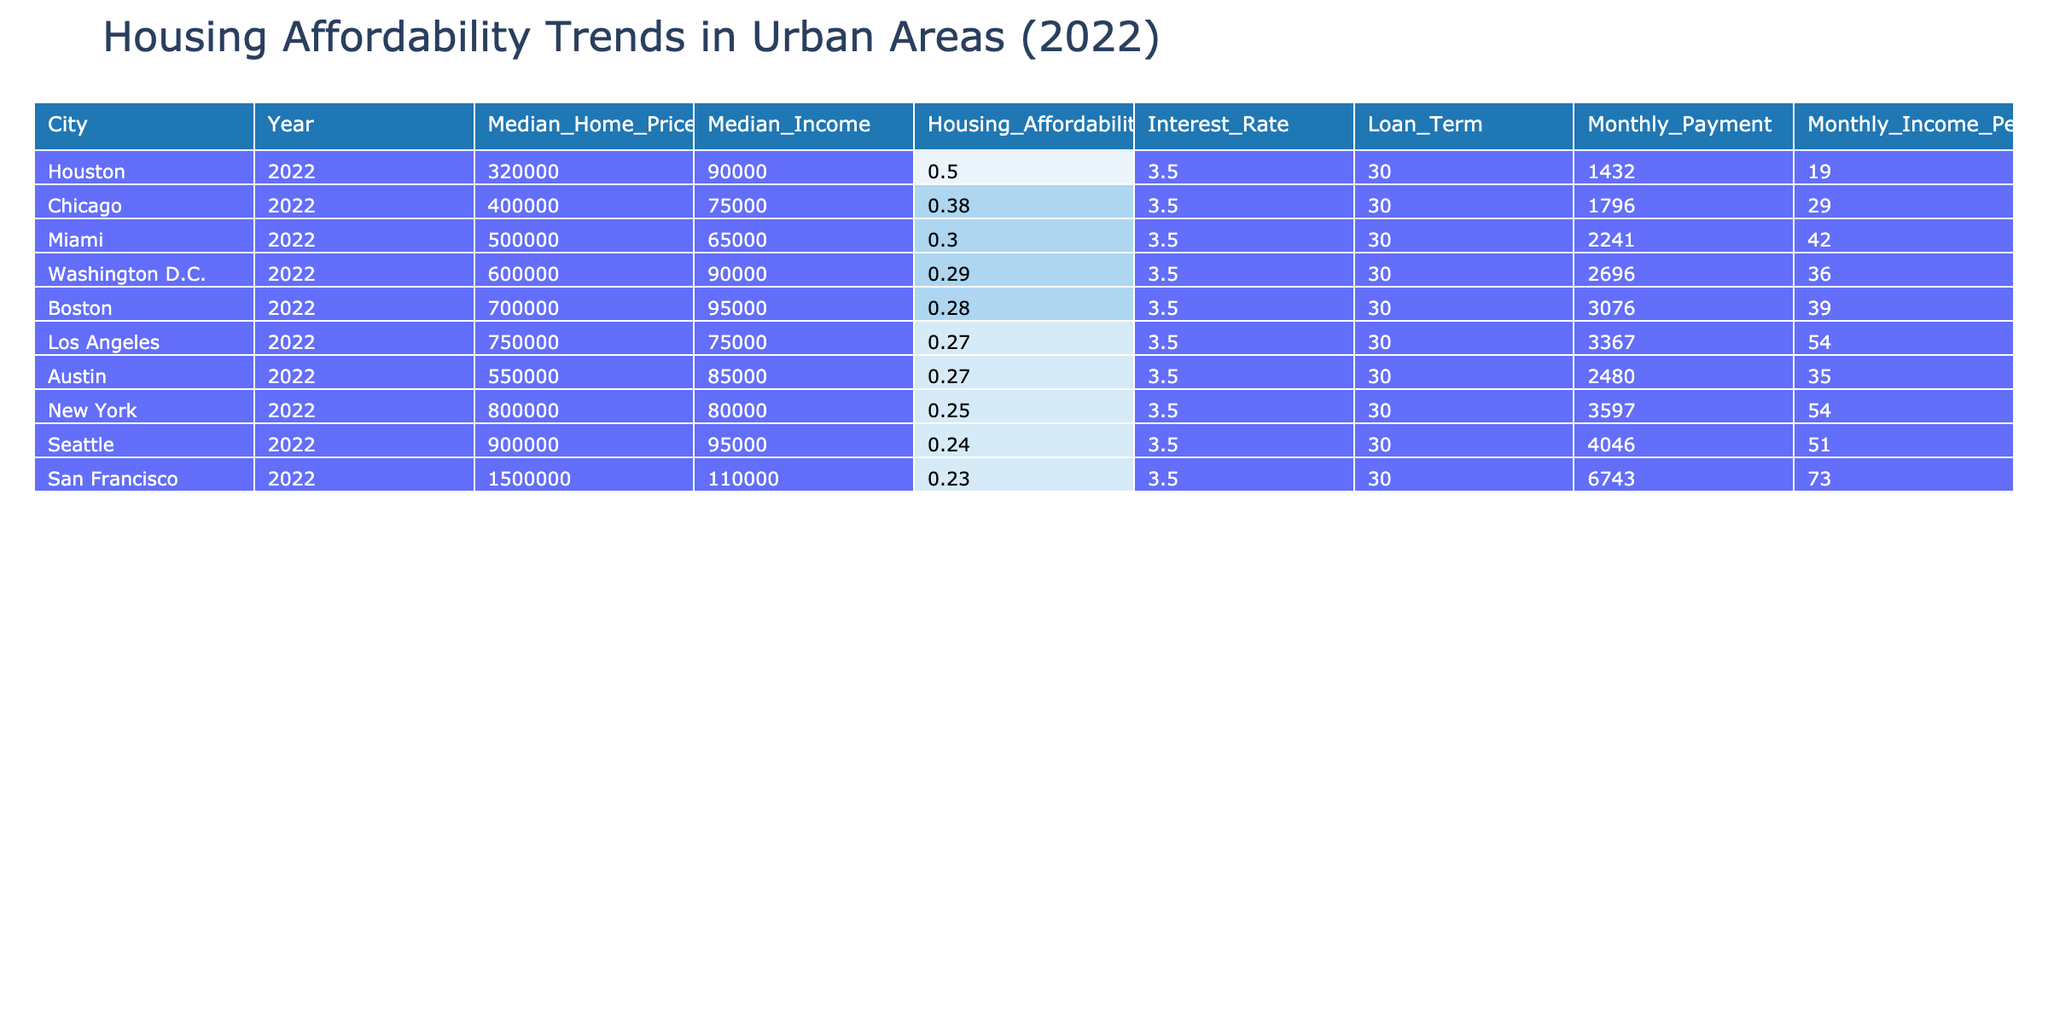What is the median home price in New York for 2022? The table presents the data for New York in 2022, where the "Median_Home_Price" is directly listed under the respective city and year. It shows a value of 800,000.
Answer: 800000 Which city has the highest housing affordability index in 2022? By sorting the "Housing_Affordability_Index" values in descending order in the table, it is clear that Chicago has the highest index at 0.38, compared to other cities listed.
Answer: Chicago What is the average monthly payment across all cities for 2022? To calculate the average monthly payment, first sum the monthly payments of all cities (3597 + 3367 + 6743 + 4046 + 1796 + 1432 + 2241 + 3076 + 2696 + 2480) = 28474. There are 10 cities, so the average is 28474/10 = 2847.4.
Answer: 2847.4 Is Miami's housing affordability index above or below 0.3 in 2022? The table shows Miami's "Housing_Affordability_Index" as 0.30, which indicates that it is equal to 0.3 but not above it. Therefore, it is not above 0.3.
Answer: No Which city has the lowest median income among the listed cities in 2022? Reviewing the "Median_Income" column, Houston has the lowest median income at 90,000, compared to other cities.
Answer: Houston What difference exists between the median home price in San Francisco and that in Chicago? The "Median_Home_Price" for San Francisco is 1,500,000 and for Chicago it is 400,000. The difference is calculated as 1,500,000 - 400,000 = 1,100,000.
Answer: 1100000 How many cities have a housing affordability index less than 0.25 in 2022? By examining the "Housing_Affordability_Index" values, only San Francisco (0.23) has a value less than 0.25, making it a total of one city.
Answer: 1 What percentage of the monthly income goes towards housing payments in Los Angeles? For Los Angeles, the "Monthly_Income_Percent" is provided as 54, indicating that 54 percent of the monthly income is spent on housing payments.
Answer: 54 What is the total monthly payment for the cities with an affordability index greater than 0.25? The cities with an affordability index greater than 0.25 are Houston (1432), Chicago (1796), and Miami (2241). Adding these values gives 1432 + 1796 + 2241 = 5470.
Answer: 5470 